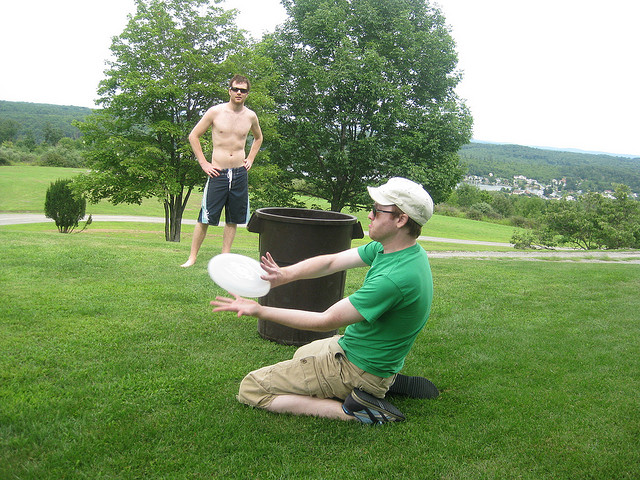What is the man wearing a hat doing? The man wearing a hat is engaging in a playful activity, specifically catching a frisbee. He is positioned on his knees on the grass, focused on the flying disc, demonstrating coordination and enjoyment in this leisure activity. 